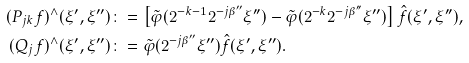<formula> <loc_0><loc_0><loc_500><loc_500>( P _ { j k } f ) ^ { \wedge } ( \xi ^ { \prime } , \xi ^ { \prime \prime } ) & \colon = \left [ \tilde { \varphi } ( 2 ^ { - k - 1 } 2 ^ { - j \beta ^ { \prime \prime } } \xi ^ { \prime \prime } ) - \tilde { \varphi } ( 2 ^ { - k } 2 ^ { - j \beta ^ { \prime \prime } } \xi ^ { \prime \prime } ) \right ] \hat { f } ( \xi ^ { \prime } , \xi ^ { \prime \prime } ) , \\ ( Q _ { j } f ) ^ { \wedge } ( \xi ^ { \prime } , \xi ^ { \prime \prime } ) & \colon = \tilde { \varphi } ( 2 ^ { - j \beta ^ { \prime \prime } } \xi ^ { \prime \prime } ) \hat { f } ( \xi ^ { \prime } , \xi ^ { \prime \prime } ) .</formula> 